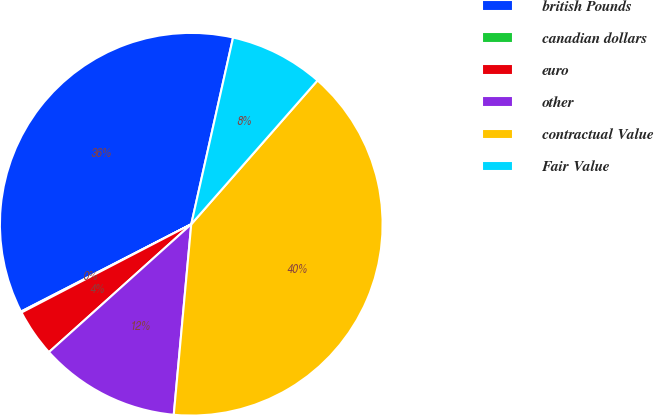<chart> <loc_0><loc_0><loc_500><loc_500><pie_chart><fcel>british Pounds<fcel>canadian dollars<fcel>euro<fcel>other<fcel>contractual Value<fcel>Fair Value<nl><fcel>36.05%<fcel>0.09%<fcel>4.02%<fcel>11.89%<fcel>39.99%<fcel>7.96%<nl></chart> 